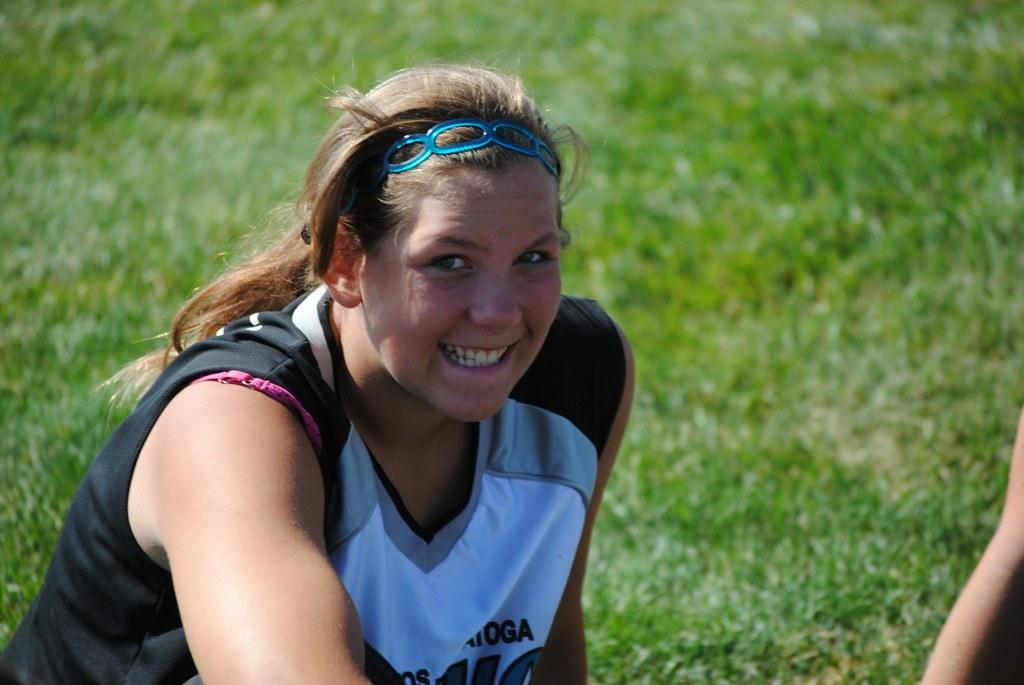What is the woman in the image doing? The woman is sitting and smiling in the image. What is the woman wearing in the image? The woman is wearing a T-shirt in the image. What accessory is the woman wearing in the image? The woman has a hair band in the image. What type of environment is visible in the image? There is grass visible in the image. How many flowers can be seen in the image? There are no flowers visible in the image. What season is depicted in the image? The season cannot be determined from the image, as there are no seasonal cues present. 